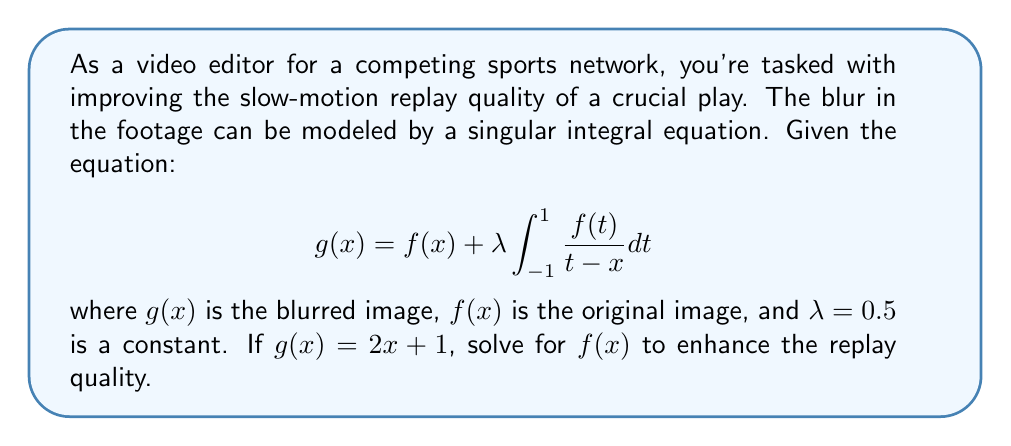Could you help me with this problem? To solve this singular integral equation, we'll follow these steps:

1) First, we recognize this as a Cauchy-type singular integral equation.

2) For such equations, we can use the Poincaré-Bertrand formula:

   $$f(x) = g(x) - \frac{\lambda}{\pi} \int_{-1}^{1} \frac{g(t)}{t-x} dt + C\sqrt{1-x^2}$$

   where $C$ is a constant to be determined.

3) We're given that $g(x) = 2x + 1$. Substituting this into the formula:

   $$f(x) = (2x + 1) - \frac{0.5}{\pi} \int_{-1}^{1} \frac{2t + 1}{t-x} dt + C\sqrt{1-x^2}$$

4) To evaluate the integral, we can split it:

   $$\int_{-1}^{1} \frac{2t + 1}{t-x} dt = 2\int_{-1}^{1} \frac{t}{t-x} dt + \int_{-1}^{1} \frac{1}{t-x} dt$$

5) The second integral is known:

   $$\int_{-1}^{1} \frac{1}{t-x} dt = \ln\left|\frac{1-x}{-1-x}\right| = \ln\left|\frac{x+1}{1-x}\right|$$

6) For the first integral:

   $$\int_{-1}^{1} \frac{t}{t-x} dt = x\ln\left|\frac{x+1}{1-x}\right| + 2$$

7) Combining these results:

   $$f(x) = (2x + 1) - \frac{0.5}{\pi} \left(2x\ln\left|\frac{x+1}{1-x}\right| + 2 + \ln\left|\frac{x+1}{1-x}\right|\right) + C\sqrt{1-x^2}$$

8) Simplifying:

   $$f(x) = 2x + 1 - \frac{1}{\pi} \left(x\ln\left|\frac{x+1}{1-x}\right| + 1\right) - \frac{0.5}{\pi} \ln\left|\frac{x+1}{1-x}\right| + C\sqrt{1-x^2}$$

9) To determine $C$, we need an additional condition, which is not provided in this problem. Therefore, we leave it as a parameter in our solution.
Answer: $$f(x) = 2x + 1 - \frac{1}{\pi} \left(x\ln\left|\frac{x+1}{1-x}\right| + 1\right) - \frac{0.5}{\pi} \ln\left|\frac{x+1}{1-x}\right| + C\sqrt{1-x^2}$$ 